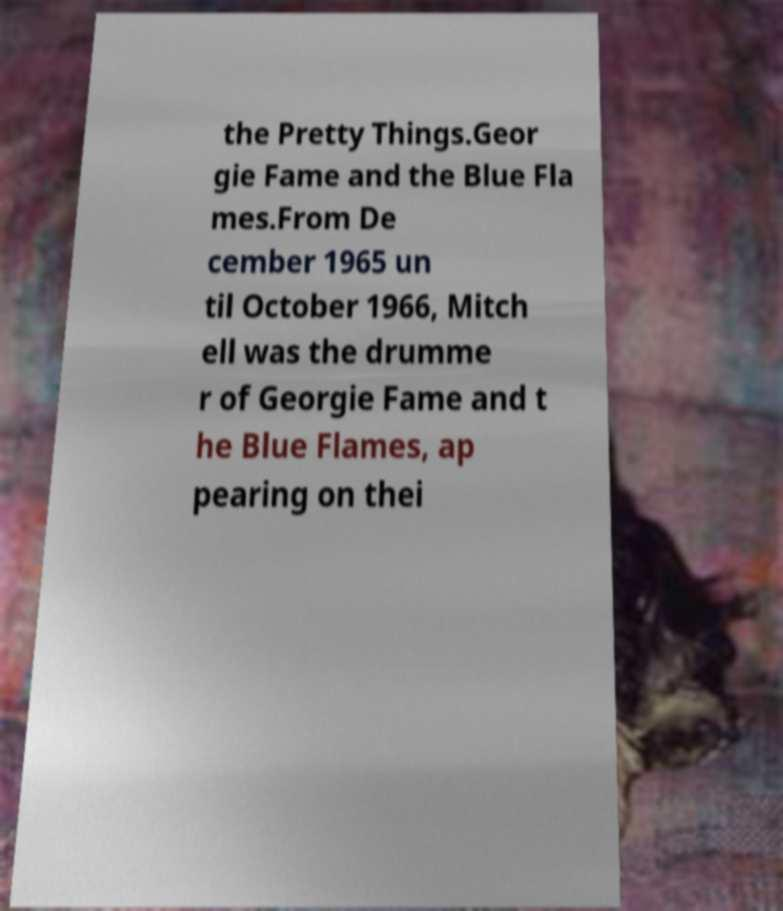Can you read and provide the text displayed in the image?This photo seems to have some interesting text. Can you extract and type it out for me? the Pretty Things.Geor gie Fame and the Blue Fla mes.From De cember 1965 un til October 1966, Mitch ell was the drumme r of Georgie Fame and t he Blue Flames, ap pearing on thei 